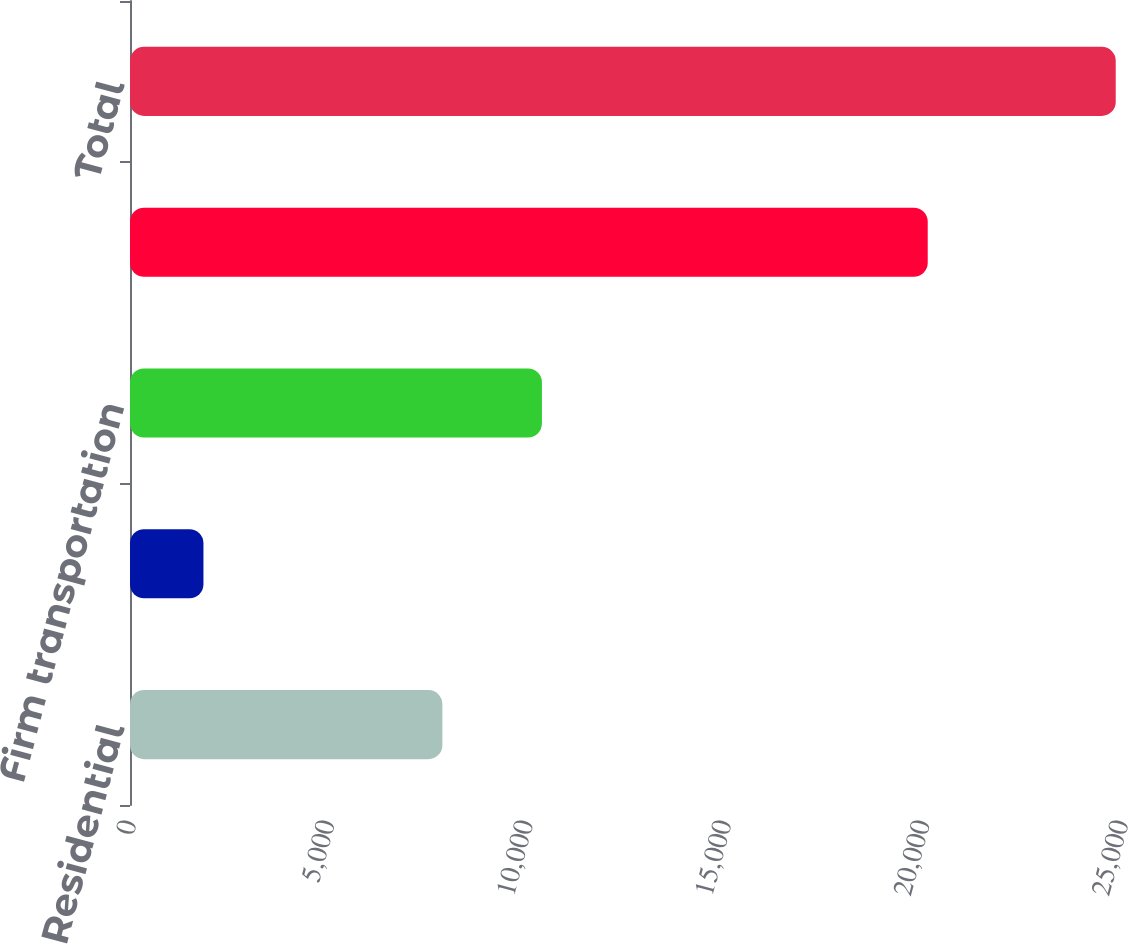Convert chart to OTSL. <chart><loc_0><loc_0><loc_500><loc_500><bar_chart><fcel>Residential<fcel>General<fcel>Firm transportation<fcel>Total firm sales and<fcel>Total<nl><fcel>7872<fcel>1851<fcel>10381<fcel>20104<fcel>24842<nl></chart> 